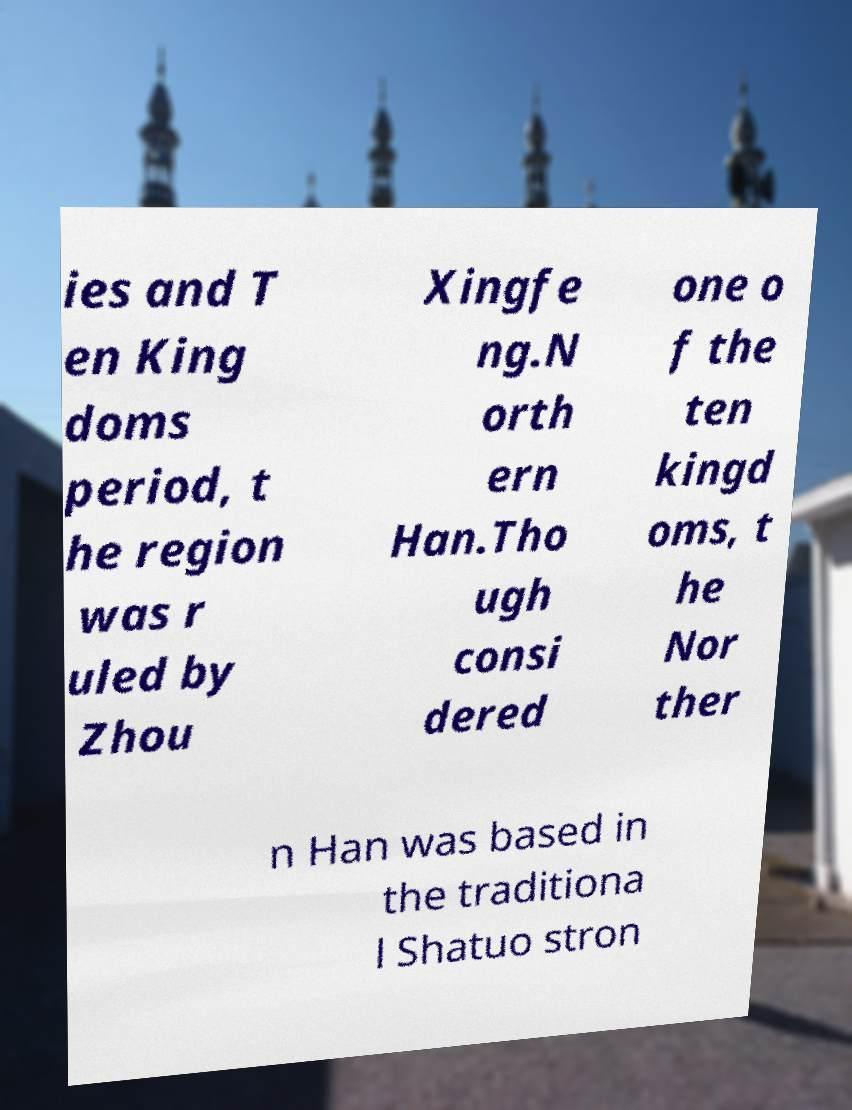Please read and relay the text visible in this image. What does it say? ies and T en King doms period, t he region was r uled by Zhou Xingfe ng.N orth ern Han.Tho ugh consi dered one o f the ten kingd oms, t he Nor ther n Han was based in the traditiona l Shatuo stron 